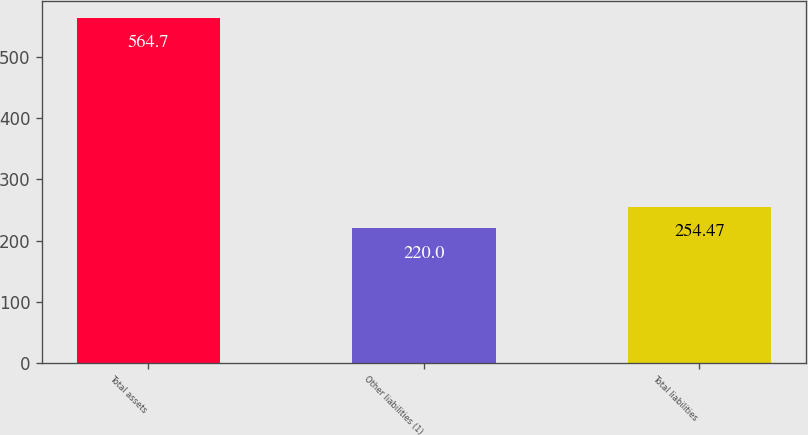Convert chart to OTSL. <chart><loc_0><loc_0><loc_500><loc_500><bar_chart><fcel>Total assets<fcel>Other liabilities (1)<fcel>Total liabilities<nl><fcel>564.7<fcel>220<fcel>254.47<nl></chart> 